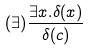<formula> <loc_0><loc_0><loc_500><loc_500>( \exists ) \frac { \exists x . \delta ( x ) } { \delta ( c ) }</formula> 